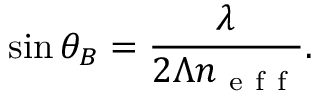Convert formula to latex. <formula><loc_0><loc_0><loc_500><loc_500>\sin \theta _ { B } = \frac { \lambda } { 2 \Lambda n _ { e f f } } .</formula> 